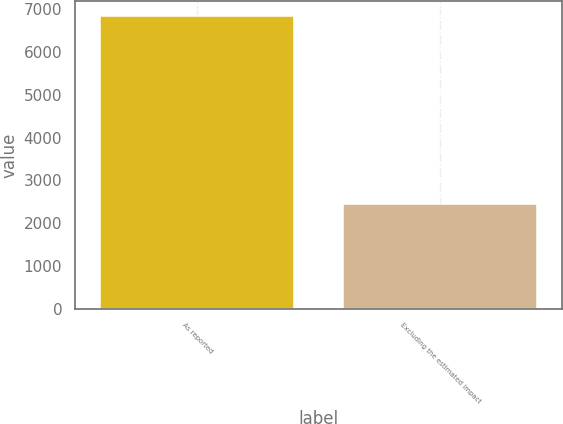Convert chart to OTSL. <chart><loc_0><loc_0><loc_500><loc_500><bar_chart><fcel>As reported<fcel>Excluding the estimated impact<nl><fcel>6846<fcel>2446<nl></chart> 